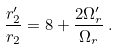Convert formula to latex. <formula><loc_0><loc_0><loc_500><loc_500>\frac { r _ { 2 } ^ { \prime } } { r _ { 2 } } = 8 + \frac { 2 \Omega _ { r } ^ { \prime } } { \Omega _ { r } } \, .</formula> 